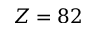Convert formula to latex. <formula><loc_0><loc_0><loc_500><loc_500>Z = 8 2</formula> 